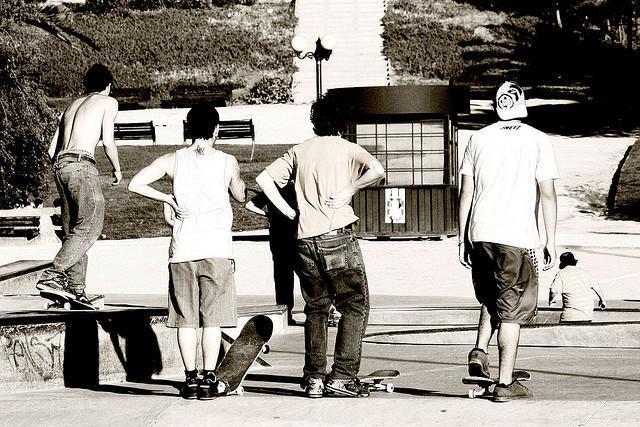How many people are shirtless?
Give a very brief answer. 1. How many people can you see?
Give a very brief answer. 6. 